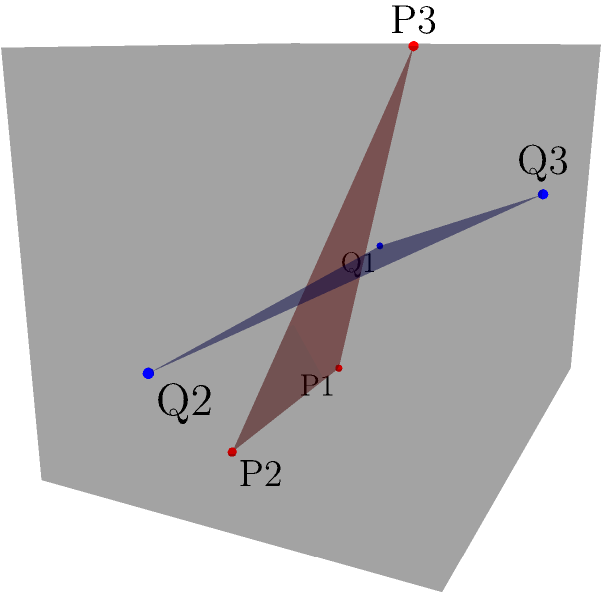In the design of a novel combustion chamber for an alternative fuel aircraft propulsion system, two intersecting planes are introduced to optimize fuel mixing. The red plane is defined by points P1(1,1,0), P2(3,1,0), and P3(2,2,3), while the blue plane is defined by points Q1(0,1,1), Q2(4,1,1), and Q3(2,3,2). Calculate the acute angle between these two planes to ensure optimal fuel-air mixture formation. To find the angle between two intersecting planes, we need to follow these steps:

1. Calculate the normal vectors of both planes:
   For the red plane (P):
   $\vec{n_1} = \overrightarrow{P1P2} \times \overrightarrow{P1P3}$
   $\overrightarrow{P1P2} = (2,0,0)$
   $\overrightarrow{P1P3} = (1,1,3)$
   $\vec{n_1} = (2,0,0) \times (1,1,3) = (0,-6,2)$

   For the blue plane (Q):
   $\vec{n_2} = \overrightarrow{Q1Q2} \times \overrightarrow{Q1Q3}$
   $\overrightarrow{Q1Q2} = (4,0,0)$
   $\overrightarrow{Q1Q3} = (2,2,1)$
   $\vec{n_2} = (4,0,0) \times (2,2,1) = (0,-4,8)$

2. Calculate the angle between the normal vectors using the dot product formula:
   $\cos \theta = \frac{\vec{n_1} \cdot \vec{n_2}}{|\vec{n_1}||\vec{n_2}|}$

3. Substitute the values:
   $\cos \theta = \frac{(0,-6,2) \cdot (0,-4,8)}{\sqrt{0^2+(-6)^2+2^2}\sqrt{0^2+(-4)^2+8^2}}$
   $= \frac{24+16}{\sqrt{40}\sqrt{80}}$
   $= \frac{40}{\sqrt{3200}}$
   $= \frac{40}{40\sqrt{2}}$
   $= \frac{1}{\sqrt{2}}$

4. Take the inverse cosine (arccos) of both sides:
   $\theta = \arccos(\frac{1}{\sqrt{2}})$

5. Convert to degrees:
   $\theta = \arccos(\frac{1}{\sqrt{2}}) \cdot \frac{180}{\pi} \approx 45°$

Therefore, the acute angle between the two planes is approximately 45°.
Answer: 45° 